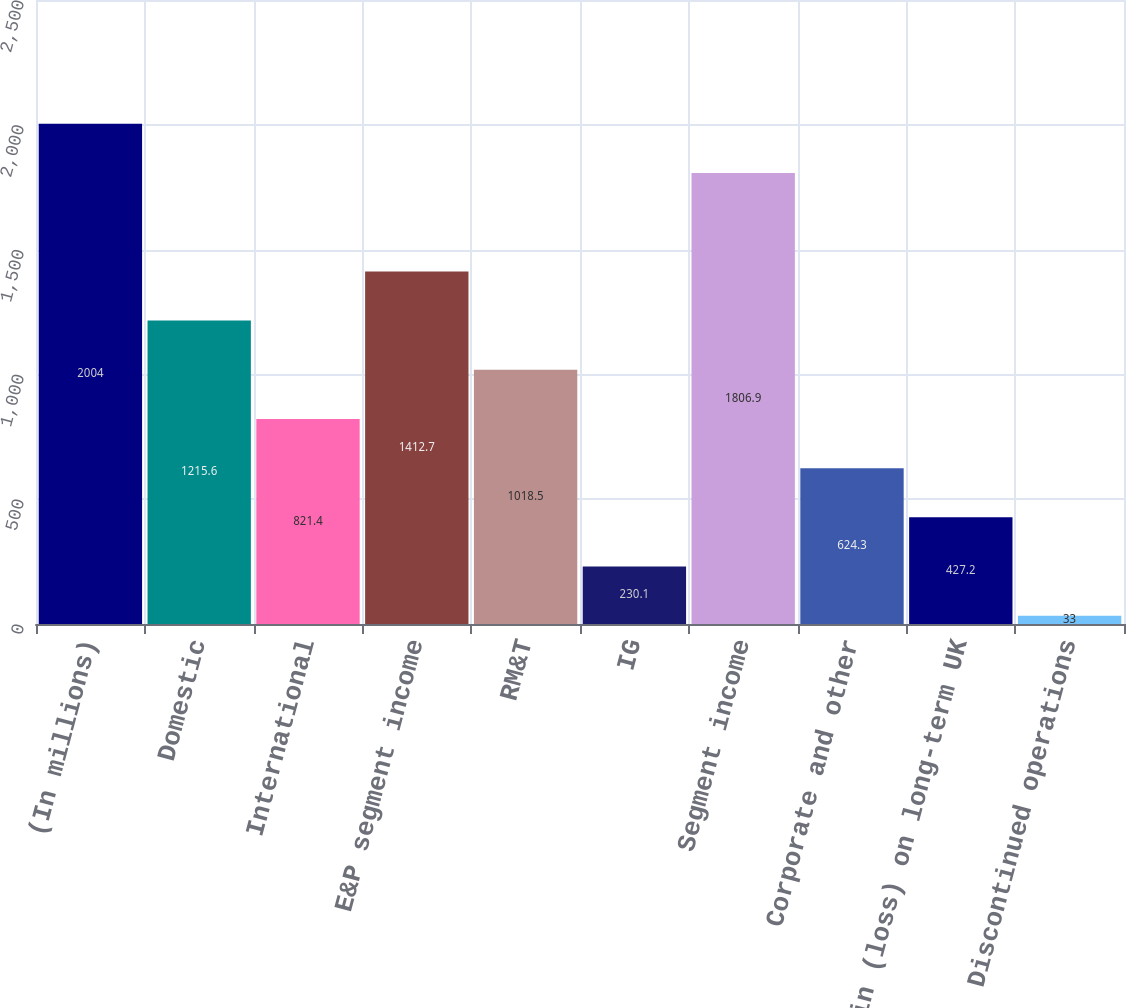Convert chart. <chart><loc_0><loc_0><loc_500><loc_500><bar_chart><fcel>(In millions)<fcel>Domestic<fcel>International<fcel>E&P segment income<fcel>RM&T<fcel>IG<fcel>Segment income<fcel>Corporate and other<fcel>Gain (loss) on long-term UK<fcel>Discontinued operations<nl><fcel>2004<fcel>1215.6<fcel>821.4<fcel>1412.7<fcel>1018.5<fcel>230.1<fcel>1806.9<fcel>624.3<fcel>427.2<fcel>33<nl></chart> 